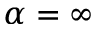Convert formula to latex. <formula><loc_0><loc_0><loc_500><loc_500>\alpha = \infty</formula> 